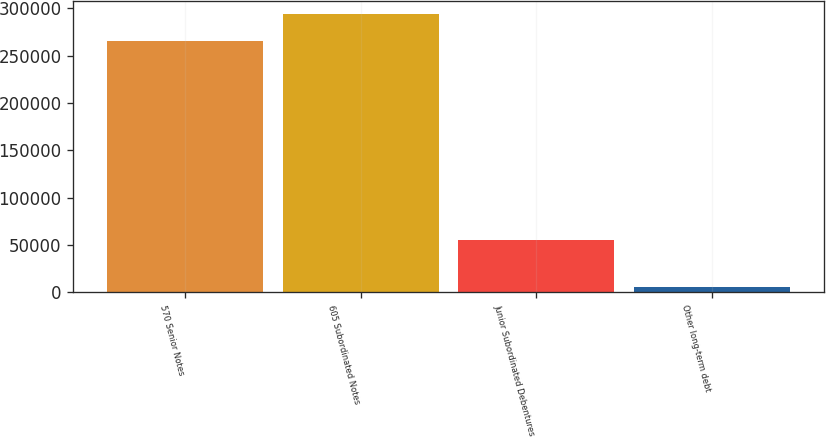Convert chart. <chart><loc_0><loc_0><loc_500><loc_500><bar_chart><fcel>570 Senior Notes<fcel>605 Subordinated Notes<fcel>Junior Subordinated Debentures<fcel>Other long-term debt<nl><fcel>265613<fcel>293681<fcel>55548<fcel>5257<nl></chart> 